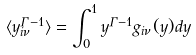<formula> <loc_0><loc_0><loc_500><loc_500>\langle y ^ { \Gamma - 1 } _ { i \nu } \rangle = \int _ { 0 } ^ { 1 } y ^ { \Gamma - 1 } g _ { i \nu } ( y ) d y</formula> 